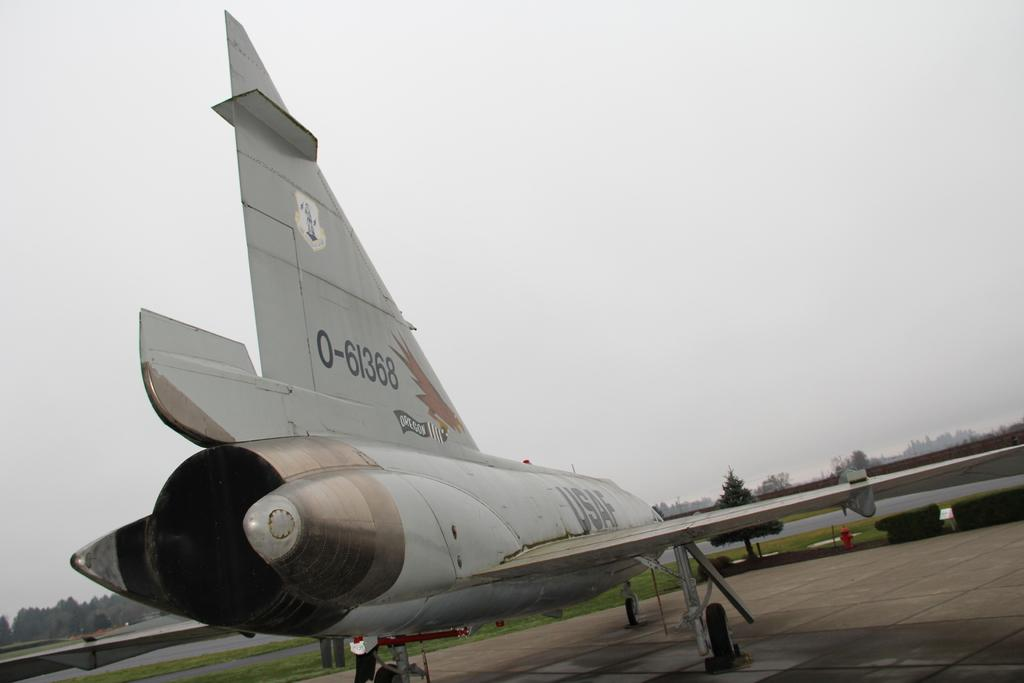<image>
Share a concise interpretation of the image provided. An airplane is on the ground with the number 0-61368 on it. 